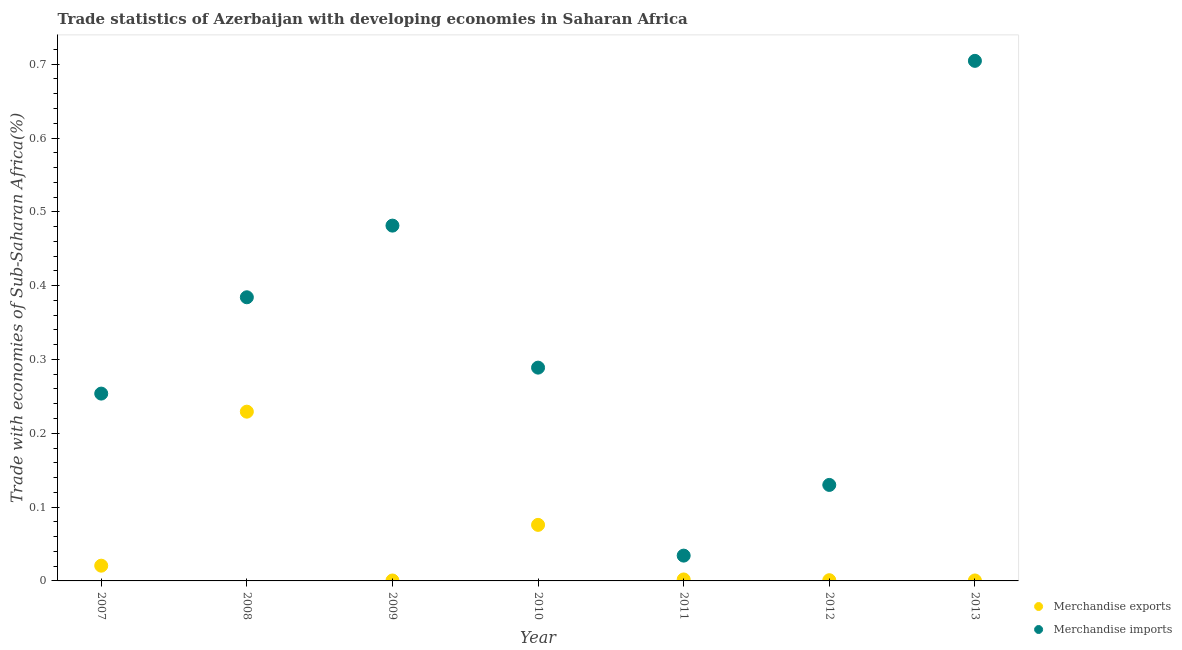How many different coloured dotlines are there?
Offer a very short reply. 2. What is the merchandise imports in 2013?
Your answer should be compact. 0.7. Across all years, what is the maximum merchandise imports?
Ensure brevity in your answer.  0.7. Across all years, what is the minimum merchandise imports?
Keep it short and to the point. 0.03. What is the total merchandise exports in the graph?
Your response must be concise. 0.33. What is the difference between the merchandise exports in 2009 and that in 2012?
Keep it short and to the point. -0. What is the difference between the merchandise imports in 2011 and the merchandise exports in 2008?
Offer a very short reply. -0.19. What is the average merchandise imports per year?
Provide a succinct answer. 0.33. In the year 2011, what is the difference between the merchandise exports and merchandise imports?
Give a very brief answer. -0.03. In how many years, is the merchandise exports greater than 0.68 %?
Your answer should be very brief. 0. What is the ratio of the merchandise imports in 2007 to that in 2009?
Offer a very short reply. 0.53. Is the merchandise exports in 2009 less than that in 2010?
Your answer should be very brief. Yes. What is the difference between the highest and the second highest merchandise imports?
Your answer should be compact. 0.22. What is the difference between the highest and the lowest merchandise imports?
Your answer should be compact. 0.67. In how many years, is the merchandise exports greater than the average merchandise exports taken over all years?
Your response must be concise. 2. Does the merchandise exports monotonically increase over the years?
Your answer should be compact. No. Is the merchandise imports strictly greater than the merchandise exports over the years?
Make the answer very short. Yes. What is the difference between two consecutive major ticks on the Y-axis?
Keep it short and to the point. 0.1. Are the values on the major ticks of Y-axis written in scientific E-notation?
Provide a short and direct response. No. What is the title of the graph?
Offer a very short reply. Trade statistics of Azerbaijan with developing economies in Saharan Africa. Does "Personal remittances" appear as one of the legend labels in the graph?
Your answer should be very brief. No. What is the label or title of the Y-axis?
Provide a short and direct response. Trade with economies of Sub-Saharan Africa(%). What is the Trade with economies of Sub-Saharan Africa(%) in Merchandise exports in 2007?
Offer a terse response. 0.02. What is the Trade with economies of Sub-Saharan Africa(%) of Merchandise imports in 2007?
Keep it short and to the point. 0.25. What is the Trade with economies of Sub-Saharan Africa(%) in Merchandise exports in 2008?
Give a very brief answer. 0.23. What is the Trade with economies of Sub-Saharan Africa(%) of Merchandise imports in 2008?
Give a very brief answer. 0.38. What is the Trade with economies of Sub-Saharan Africa(%) of Merchandise exports in 2009?
Provide a short and direct response. 0. What is the Trade with economies of Sub-Saharan Africa(%) in Merchandise imports in 2009?
Your answer should be compact. 0.48. What is the Trade with economies of Sub-Saharan Africa(%) in Merchandise exports in 2010?
Your answer should be compact. 0.08. What is the Trade with economies of Sub-Saharan Africa(%) in Merchandise imports in 2010?
Make the answer very short. 0.29. What is the Trade with economies of Sub-Saharan Africa(%) in Merchandise exports in 2011?
Provide a short and direct response. 0. What is the Trade with economies of Sub-Saharan Africa(%) in Merchandise imports in 2011?
Give a very brief answer. 0.03. What is the Trade with economies of Sub-Saharan Africa(%) of Merchandise exports in 2012?
Your answer should be compact. 0. What is the Trade with economies of Sub-Saharan Africa(%) of Merchandise imports in 2012?
Make the answer very short. 0.13. What is the Trade with economies of Sub-Saharan Africa(%) in Merchandise exports in 2013?
Provide a succinct answer. 0. What is the Trade with economies of Sub-Saharan Africa(%) in Merchandise imports in 2013?
Offer a very short reply. 0.7. Across all years, what is the maximum Trade with economies of Sub-Saharan Africa(%) in Merchandise exports?
Your answer should be compact. 0.23. Across all years, what is the maximum Trade with economies of Sub-Saharan Africa(%) in Merchandise imports?
Your response must be concise. 0.7. Across all years, what is the minimum Trade with economies of Sub-Saharan Africa(%) of Merchandise exports?
Keep it short and to the point. 0. Across all years, what is the minimum Trade with economies of Sub-Saharan Africa(%) in Merchandise imports?
Make the answer very short. 0.03. What is the total Trade with economies of Sub-Saharan Africa(%) in Merchandise exports in the graph?
Give a very brief answer. 0.33. What is the total Trade with economies of Sub-Saharan Africa(%) of Merchandise imports in the graph?
Make the answer very short. 2.28. What is the difference between the Trade with economies of Sub-Saharan Africa(%) in Merchandise exports in 2007 and that in 2008?
Ensure brevity in your answer.  -0.21. What is the difference between the Trade with economies of Sub-Saharan Africa(%) of Merchandise imports in 2007 and that in 2008?
Offer a very short reply. -0.13. What is the difference between the Trade with economies of Sub-Saharan Africa(%) of Merchandise imports in 2007 and that in 2009?
Ensure brevity in your answer.  -0.23. What is the difference between the Trade with economies of Sub-Saharan Africa(%) of Merchandise exports in 2007 and that in 2010?
Provide a succinct answer. -0.06. What is the difference between the Trade with economies of Sub-Saharan Africa(%) of Merchandise imports in 2007 and that in 2010?
Keep it short and to the point. -0.04. What is the difference between the Trade with economies of Sub-Saharan Africa(%) in Merchandise exports in 2007 and that in 2011?
Offer a terse response. 0.02. What is the difference between the Trade with economies of Sub-Saharan Africa(%) in Merchandise imports in 2007 and that in 2011?
Keep it short and to the point. 0.22. What is the difference between the Trade with economies of Sub-Saharan Africa(%) of Merchandise exports in 2007 and that in 2012?
Keep it short and to the point. 0.02. What is the difference between the Trade with economies of Sub-Saharan Africa(%) in Merchandise imports in 2007 and that in 2012?
Your response must be concise. 0.12. What is the difference between the Trade with economies of Sub-Saharan Africa(%) of Merchandise exports in 2007 and that in 2013?
Make the answer very short. 0.02. What is the difference between the Trade with economies of Sub-Saharan Africa(%) in Merchandise imports in 2007 and that in 2013?
Your response must be concise. -0.45. What is the difference between the Trade with economies of Sub-Saharan Africa(%) in Merchandise exports in 2008 and that in 2009?
Your answer should be compact. 0.23. What is the difference between the Trade with economies of Sub-Saharan Africa(%) of Merchandise imports in 2008 and that in 2009?
Ensure brevity in your answer.  -0.1. What is the difference between the Trade with economies of Sub-Saharan Africa(%) in Merchandise exports in 2008 and that in 2010?
Offer a terse response. 0.15. What is the difference between the Trade with economies of Sub-Saharan Africa(%) in Merchandise imports in 2008 and that in 2010?
Your answer should be compact. 0.1. What is the difference between the Trade with economies of Sub-Saharan Africa(%) in Merchandise exports in 2008 and that in 2011?
Offer a terse response. 0.23. What is the difference between the Trade with economies of Sub-Saharan Africa(%) in Merchandise imports in 2008 and that in 2011?
Offer a terse response. 0.35. What is the difference between the Trade with economies of Sub-Saharan Africa(%) in Merchandise exports in 2008 and that in 2012?
Your response must be concise. 0.23. What is the difference between the Trade with economies of Sub-Saharan Africa(%) of Merchandise imports in 2008 and that in 2012?
Ensure brevity in your answer.  0.25. What is the difference between the Trade with economies of Sub-Saharan Africa(%) in Merchandise exports in 2008 and that in 2013?
Your answer should be compact. 0.23. What is the difference between the Trade with economies of Sub-Saharan Africa(%) of Merchandise imports in 2008 and that in 2013?
Give a very brief answer. -0.32. What is the difference between the Trade with economies of Sub-Saharan Africa(%) in Merchandise exports in 2009 and that in 2010?
Provide a succinct answer. -0.08. What is the difference between the Trade with economies of Sub-Saharan Africa(%) in Merchandise imports in 2009 and that in 2010?
Offer a terse response. 0.19. What is the difference between the Trade with economies of Sub-Saharan Africa(%) in Merchandise exports in 2009 and that in 2011?
Give a very brief answer. -0. What is the difference between the Trade with economies of Sub-Saharan Africa(%) in Merchandise imports in 2009 and that in 2011?
Ensure brevity in your answer.  0.45. What is the difference between the Trade with economies of Sub-Saharan Africa(%) in Merchandise exports in 2009 and that in 2012?
Make the answer very short. -0. What is the difference between the Trade with economies of Sub-Saharan Africa(%) in Merchandise imports in 2009 and that in 2012?
Keep it short and to the point. 0.35. What is the difference between the Trade with economies of Sub-Saharan Africa(%) of Merchandise imports in 2009 and that in 2013?
Provide a succinct answer. -0.22. What is the difference between the Trade with economies of Sub-Saharan Africa(%) in Merchandise exports in 2010 and that in 2011?
Keep it short and to the point. 0.07. What is the difference between the Trade with economies of Sub-Saharan Africa(%) in Merchandise imports in 2010 and that in 2011?
Give a very brief answer. 0.25. What is the difference between the Trade with economies of Sub-Saharan Africa(%) of Merchandise exports in 2010 and that in 2012?
Offer a very short reply. 0.07. What is the difference between the Trade with economies of Sub-Saharan Africa(%) of Merchandise imports in 2010 and that in 2012?
Make the answer very short. 0.16. What is the difference between the Trade with economies of Sub-Saharan Africa(%) of Merchandise exports in 2010 and that in 2013?
Keep it short and to the point. 0.08. What is the difference between the Trade with economies of Sub-Saharan Africa(%) in Merchandise imports in 2010 and that in 2013?
Provide a short and direct response. -0.42. What is the difference between the Trade with economies of Sub-Saharan Africa(%) in Merchandise exports in 2011 and that in 2012?
Your answer should be compact. 0. What is the difference between the Trade with economies of Sub-Saharan Africa(%) of Merchandise imports in 2011 and that in 2012?
Your answer should be compact. -0.1. What is the difference between the Trade with economies of Sub-Saharan Africa(%) in Merchandise exports in 2011 and that in 2013?
Make the answer very short. 0. What is the difference between the Trade with economies of Sub-Saharan Africa(%) in Merchandise imports in 2011 and that in 2013?
Make the answer very short. -0.67. What is the difference between the Trade with economies of Sub-Saharan Africa(%) in Merchandise exports in 2012 and that in 2013?
Provide a succinct answer. 0. What is the difference between the Trade with economies of Sub-Saharan Africa(%) in Merchandise imports in 2012 and that in 2013?
Your response must be concise. -0.57. What is the difference between the Trade with economies of Sub-Saharan Africa(%) of Merchandise exports in 2007 and the Trade with economies of Sub-Saharan Africa(%) of Merchandise imports in 2008?
Your answer should be very brief. -0.36. What is the difference between the Trade with economies of Sub-Saharan Africa(%) of Merchandise exports in 2007 and the Trade with economies of Sub-Saharan Africa(%) of Merchandise imports in 2009?
Make the answer very short. -0.46. What is the difference between the Trade with economies of Sub-Saharan Africa(%) in Merchandise exports in 2007 and the Trade with economies of Sub-Saharan Africa(%) in Merchandise imports in 2010?
Your answer should be compact. -0.27. What is the difference between the Trade with economies of Sub-Saharan Africa(%) of Merchandise exports in 2007 and the Trade with economies of Sub-Saharan Africa(%) of Merchandise imports in 2011?
Offer a very short reply. -0.01. What is the difference between the Trade with economies of Sub-Saharan Africa(%) of Merchandise exports in 2007 and the Trade with economies of Sub-Saharan Africa(%) of Merchandise imports in 2012?
Offer a terse response. -0.11. What is the difference between the Trade with economies of Sub-Saharan Africa(%) of Merchandise exports in 2007 and the Trade with economies of Sub-Saharan Africa(%) of Merchandise imports in 2013?
Offer a terse response. -0.68. What is the difference between the Trade with economies of Sub-Saharan Africa(%) in Merchandise exports in 2008 and the Trade with economies of Sub-Saharan Africa(%) in Merchandise imports in 2009?
Provide a succinct answer. -0.25. What is the difference between the Trade with economies of Sub-Saharan Africa(%) in Merchandise exports in 2008 and the Trade with economies of Sub-Saharan Africa(%) in Merchandise imports in 2010?
Offer a terse response. -0.06. What is the difference between the Trade with economies of Sub-Saharan Africa(%) in Merchandise exports in 2008 and the Trade with economies of Sub-Saharan Africa(%) in Merchandise imports in 2011?
Make the answer very short. 0.2. What is the difference between the Trade with economies of Sub-Saharan Africa(%) of Merchandise exports in 2008 and the Trade with economies of Sub-Saharan Africa(%) of Merchandise imports in 2012?
Provide a succinct answer. 0.1. What is the difference between the Trade with economies of Sub-Saharan Africa(%) of Merchandise exports in 2008 and the Trade with economies of Sub-Saharan Africa(%) of Merchandise imports in 2013?
Give a very brief answer. -0.48. What is the difference between the Trade with economies of Sub-Saharan Africa(%) in Merchandise exports in 2009 and the Trade with economies of Sub-Saharan Africa(%) in Merchandise imports in 2010?
Your answer should be compact. -0.29. What is the difference between the Trade with economies of Sub-Saharan Africa(%) in Merchandise exports in 2009 and the Trade with economies of Sub-Saharan Africa(%) in Merchandise imports in 2011?
Your response must be concise. -0.03. What is the difference between the Trade with economies of Sub-Saharan Africa(%) of Merchandise exports in 2009 and the Trade with economies of Sub-Saharan Africa(%) of Merchandise imports in 2012?
Your answer should be compact. -0.13. What is the difference between the Trade with economies of Sub-Saharan Africa(%) of Merchandise exports in 2009 and the Trade with economies of Sub-Saharan Africa(%) of Merchandise imports in 2013?
Give a very brief answer. -0.7. What is the difference between the Trade with economies of Sub-Saharan Africa(%) in Merchandise exports in 2010 and the Trade with economies of Sub-Saharan Africa(%) in Merchandise imports in 2011?
Ensure brevity in your answer.  0.04. What is the difference between the Trade with economies of Sub-Saharan Africa(%) in Merchandise exports in 2010 and the Trade with economies of Sub-Saharan Africa(%) in Merchandise imports in 2012?
Make the answer very short. -0.05. What is the difference between the Trade with economies of Sub-Saharan Africa(%) in Merchandise exports in 2010 and the Trade with economies of Sub-Saharan Africa(%) in Merchandise imports in 2013?
Provide a short and direct response. -0.63. What is the difference between the Trade with economies of Sub-Saharan Africa(%) in Merchandise exports in 2011 and the Trade with economies of Sub-Saharan Africa(%) in Merchandise imports in 2012?
Provide a succinct answer. -0.13. What is the difference between the Trade with economies of Sub-Saharan Africa(%) of Merchandise exports in 2011 and the Trade with economies of Sub-Saharan Africa(%) of Merchandise imports in 2013?
Give a very brief answer. -0.7. What is the difference between the Trade with economies of Sub-Saharan Africa(%) of Merchandise exports in 2012 and the Trade with economies of Sub-Saharan Africa(%) of Merchandise imports in 2013?
Offer a very short reply. -0.7. What is the average Trade with economies of Sub-Saharan Africa(%) in Merchandise exports per year?
Your response must be concise. 0.05. What is the average Trade with economies of Sub-Saharan Africa(%) of Merchandise imports per year?
Give a very brief answer. 0.33. In the year 2007, what is the difference between the Trade with economies of Sub-Saharan Africa(%) of Merchandise exports and Trade with economies of Sub-Saharan Africa(%) of Merchandise imports?
Keep it short and to the point. -0.23. In the year 2008, what is the difference between the Trade with economies of Sub-Saharan Africa(%) of Merchandise exports and Trade with economies of Sub-Saharan Africa(%) of Merchandise imports?
Make the answer very short. -0.15. In the year 2009, what is the difference between the Trade with economies of Sub-Saharan Africa(%) in Merchandise exports and Trade with economies of Sub-Saharan Africa(%) in Merchandise imports?
Your answer should be very brief. -0.48. In the year 2010, what is the difference between the Trade with economies of Sub-Saharan Africa(%) in Merchandise exports and Trade with economies of Sub-Saharan Africa(%) in Merchandise imports?
Ensure brevity in your answer.  -0.21. In the year 2011, what is the difference between the Trade with economies of Sub-Saharan Africa(%) in Merchandise exports and Trade with economies of Sub-Saharan Africa(%) in Merchandise imports?
Provide a succinct answer. -0.03. In the year 2012, what is the difference between the Trade with economies of Sub-Saharan Africa(%) in Merchandise exports and Trade with economies of Sub-Saharan Africa(%) in Merchandise imports?
Your answer should be very brief. -0.13. In the year 2013, what is the difference between the Trade with economies of Sub-Saharan Africa(%) in Merchandise exports and Trade with economies of Sub-Saharan Africa(%) in Merchandise imports?
Your answer should be compact. -0.7. What is the ratio of the Trade with economies of Sub-Saharan Africa(%) in Merchandise exports in 2007 to that in 2008?
Your answer should be very brief. 0.09. What is the ratio of the Trade with economies of Sub-Saharan Africa(%) in Merchandise imports in 2007 to that in 2008?
Offer a very short reply. 0.66. What is the ratio of the Trade with economies of Sub-Saharan Africa(%) in Merchandise exports in 2007 to that in 2009?
Your response must be concise. 34.88. What is the ratio of the Trade with economies of Sub-Saharan Africa(%) in Merchandise imports in 2007 to that in 2009?
Offer a terse response. 0.53. What is the ratio of the Trade with economies of Sub-Saharan Africa(%) in Merchandise exports in 2007 to that in 2010?
Keep it short and to the point. 0.27. What is the ratio of the Trade with economies of Sub-Saharan Africa(%) in Merchandise imports in 2007 to that in 2010?
Ensure brevity in your answer.  0.88. What is the ratio of the Trade with economies of Sub-Saharan Africa(%) in Merchandise exports in 2007 to that in 2011?
Ensure brevity in your answer.  10.4. What is the ratio of the Trade with economies of Sub-Saharan Africa(%) in Merchandise imports in 2007 to that in 2011?
Your answer should be very brief. 7.4. What is the ratio of the Trade with economies of Sub-Saharan Africa(%) of Merchandise exports in 2007 to that in 2012?
Give a very brief answer. 21.05. What is the ratio of the Trade with economies of Sub-Saharan Africa(%) in Merchandise imports in 2007 to that in 2012?
Keep it short and to the point. 1.95. What is the ratio of the Trade with economies of Sub-Saharan Africa(%) of Merchandise exports in 2007 to that in 2013?
Give a very brief answer. 32.58. What is the ratio of the Trade with economies of Sub-Saharan Africa(%) in Merchandise imports in 2007 to that in 2013?
Provide a succinct answer. 0.36. What is the ratio of the Trade with economies of Sub-Saharan Africa(%) in Merchandise exports in 2008 to that in 2009?
Your answer should be very brief. 387.43. What is the ratio of the Trade with economies of Sub-Saharan Africa(%) in Merchandise imports in 2008 to that in 2009?
Provide a succinct answer. 0.8. What is the ratio of the Trade with economies of Sub-Saharan Africa(%) of Merchandise exports in 2008 to that in 2010?
Provide a short and direct response. 3.02. What is the ratio of the Trade with economies of Sub-Saharan Africa(%) in Merchandise imports in 2008 to that in 2010?
Make the answer very short. 1.33. What is the ratio of the Trade with economies of Sub-Saharan Africa(%) in Merchandise exports in 2008 to that in 2011?
Your answer should be compact. 115.58. What is the ratio of the Trade with economies of Sub-Saharan Africa(%) in Merchandise imports in 2008 to that in 2011?
Your answer should be very brief. 11.21. What is the ratio of the Trade with economies of Sub-Saharan Africa(%) in Merchandise exports in 2008 to that in 2012?
Your response must be concise. 233.85. What is the ratio of the Trade with economies of Sub-Saharan Africa(%) in Merchandise imports in 2008 to that in 2012?
Offer a very short reply. 2.95. What is the ratio of the Trade with economies of Sub-Saharan Africa(%) of Merchandise exports in 2008 to that in 2013?
Ensure brevity in your answer.  361.88. What is the ratio of the Trade with economies of Sub-Saharan Africa(%) in Merchandise imports in 2008 to that in 2013?
Keep it short and to the point. 0.55. What is the ratio of the Trade with economies of Sub-Saharan Africa(%) in Merchandise exports in 2009 to that in 2010?
Your answer should be compact. 0.01. What is the ratio of the Trade with economies of Sub-Saharan Africa(%) in Merchandise imports in 2009 to that in 2010?
Your response must be concise. 1.67. What is the ratio of the Trade with economies of Sub-Saharan Africa(%) in Merchandise exports in 2009 to that in 2011?
Provide a succinct answer. 0.3. What is the ratio of the Trade with economies of Sub-Saharan Africa(%) of Merchandise imports in 2009 to that in 2011?
Your answer should be compact. 14.04. What is the ratio of the Trade with economies of Sub-Saharan Africa(%) of Merchandise exports in 2009 to that in 2012?
Ensure brevity in your answer.  0.6. What is the ratio of the Trade with economies of Sub-Saharan Africa(%) in Merchandise imports in 2009 to that in 2012?
Your answer should be compact. 3.7. What is the ratio of the Trade with economies of Sub-Saharan Africa(%) in Merchandise exports in 2009 to that in 2013?
Make the answer very short. 0.93. What is the ratio of the Trade with economies of Sub-Saharan Africa(%) of Merchandise imports in 2009 to that in 2013?
Keep it short and to the point. 0.68. What is the ratio of the Trade with economies of Sub-Saharan Africa(%) of Merchandise exports in 2010 to that in 2011?
Ensure brevity in your answer.  38.27. What is the ratio of the Trade with economies of Sub-Saharan Africa(%) of Merchandise imports in 2010 to that in 2011?
Offer a terse response. 8.43. What is the ratio of the Trade with economies of Sub-Saharan Africa(%) in Merchandise exports in 2010 to that in 2012?
Offer a terse response. 77.44. What is the ratio of the Trade with economies of Sub-Saharan Africa(%) in Merchandise imports in 2010 to that in 2012?
Give a very brief answer. 2.22. What is the ratio of the Trade with economies of Sub-Saharan Africa(%) of Merchandise exports in 2010 to that in 2013?
Keep it short and to the point. 119.84. What is the ratio of the Trade with economies of Sub-Saharan Africa(%) of Merchandise imports in 2010 to that in 2013?
Offer a very short reply. 0.41. What is the ratio of the Trade with economies of Sub-Saharan Africa(%) in Merchandise exports in 2011 to that in 2012?
Give a very brief answer. 2.02. What is the ratio of the Trade with economies of Sub-Saharan Africa(%) of Merchandise imports in 2011 to that in 2012?
Give a very brief answer. 0.26. What is the ratio of the Trade with economies of Sub-Saharan Africa(%) in Merchandise exports in 2011 to that in 2013?
Offer a very short reply. 3.13. What is the ratio of the Trade with economies of Sub-Saharan Africa(%) of Merchandise imports in 2011 to that in 2013?
Your answer should be very brief. 0.05. What is the ratio of the Trade with economies of Sub-Saharan Africa(%) of Merchandise exports in 2012 to that in 2013?
Give a very brief answer. 1.55. What is the ratio of the Trade with economies of Sub-Saharan Africa(%) of Merchandise imports in 2012 to that in 2013?
Offer a terse response. 0.18. What is the difference between the highest and the second highest Trade with economies of Sub-Saharan Africa(%) in Merchandise exports?
Keep it short and to the point. 0.15. What is the difference between the highest and the second highest Trade with economies of Sub-Saharan Africa(%) in Merchandise imports?
Your answer should be very brief. 0.22. What is the difference between the highest and the lowest Trade with economies of Sub-Saharan Africa(%) in Merchandise exports?
Make the answer very short. 0.23. What is the difference between the highest and the lowest Trade with economies of Sub-Saharan Africa(%) of Merchandise imports?
Your answer should be very brief. 0.67. 